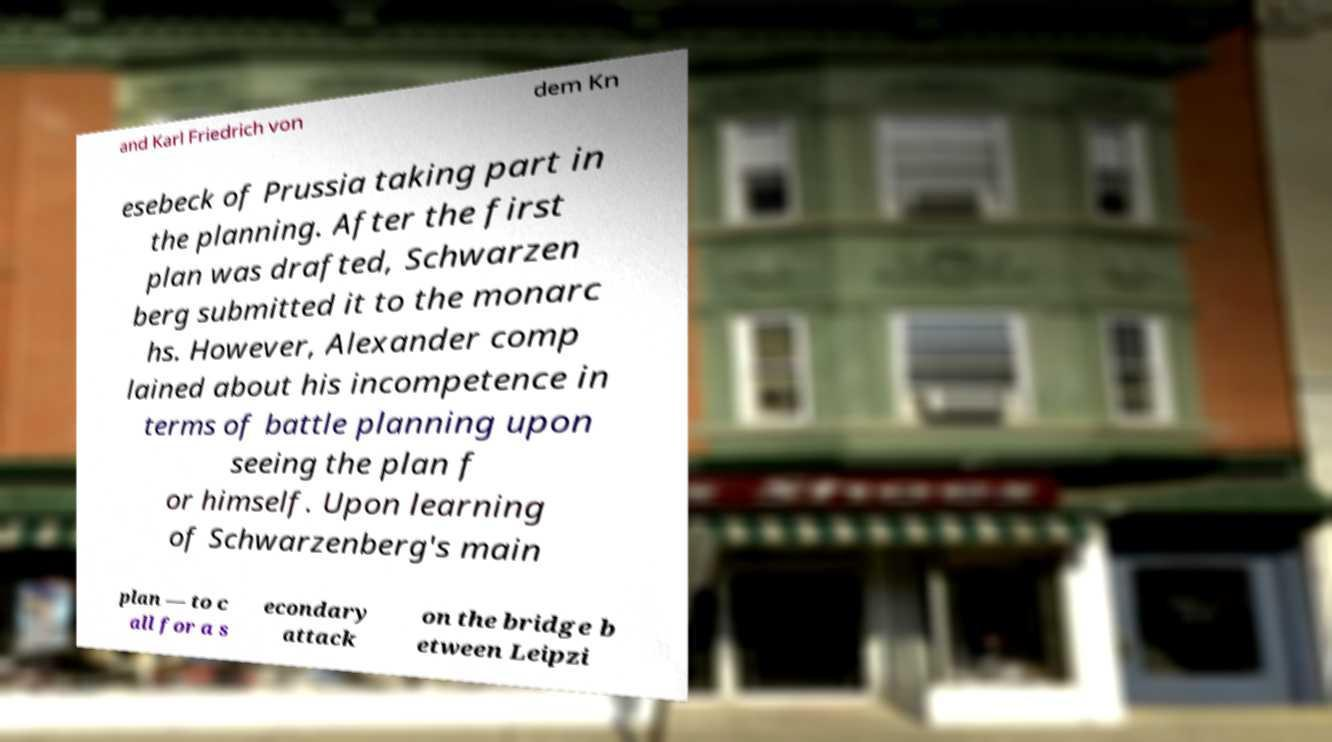For documentation purposes, I need the text within this image transcribed. Could you provide that? and Karl Friedrich von dem Kn esebeck of Prussia taking part in the planning. After the first plan was drafted, Schwarzen berg submitted it to the monarc hs. However, Alexander comp lained about his incompetence in terms of battle planning upon seeing the plan f or himself. Upon learning of Schwarzenberg's main plan — to c all for a s econdary attack on the bridge b etween Leipzi 